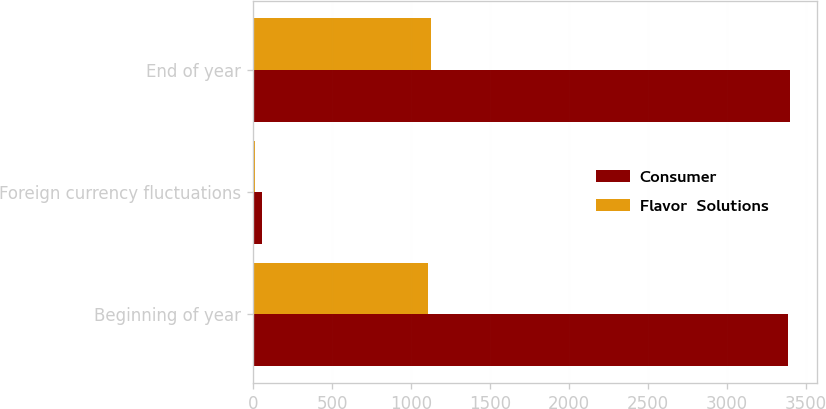Convert chart to OTSL. <chart><loc_0><loc_0><loc_500><loc_500><stacked_bar_chart><ecel><fcel>Beginning of year<fcel>Foreign currency fluctuations<fcel>End of year<nl><fcel>Consumer<fcel>3385.4<fcel>54.6<fcel>3398.9<nl><fcel>Flavor  Solutions<fcel>1104.7<fcel>9.8<fcel>1129<nl></chart> 